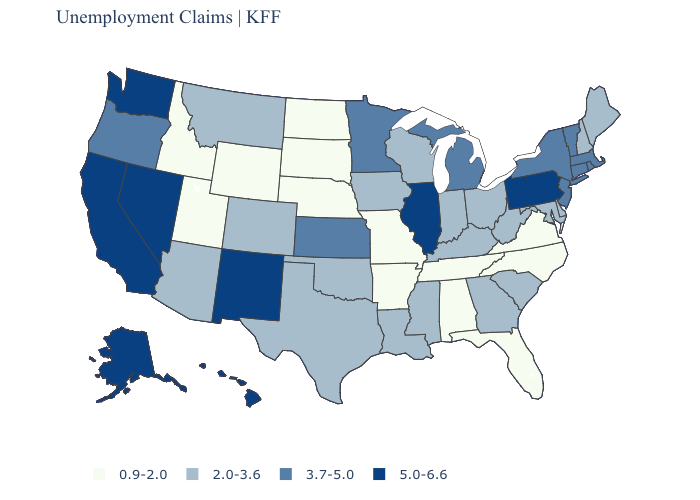Does Vermont have the lowest value in the USA?
Be succinct. No. Does Washington have the highest value in the West?
Answer briefly. Yes. Which states have the lowest value in the Northeast?
Concise answer only. Maine, New Hampshire. What is the highest value in the USA?
Be succinct. 5.0-6.6. Does Minnesota have the lowest value in the USA?
Short answer required. No. Name the states that have a value in the range 5.0-6.6?
Be succinct. Alaska, California, Hawaii, Illinois, Nevada, New Mexico, Pennsylvania, Washington. What is the value of Delaware?
Quick response, please. 2.0-3.6. Among the states that border Montana , which have the highest value?
Quick response, please. Idaho, North Dakota, South Dakota, Wyoming. Among the states that border Pennsylvania , does New York have the lowest value?
Give a very brief answer. No. Name the states that have a value in the range 0.9-2.0?
Be succinct. Alabama, Arkansas, Florida, Idaho, Missouri, Nebraska, North Carolina, North Dakota, South Dakota, Tennessee, Utah, Virginia, Wyoming. Name the states that have a value in the range 3.7-5.0?
Give a very brief answer. Connecticut, Kansas, Massachusetts, Michigan, Minnesota, New Jersey, New York, Oregon, Rhode Island, Vermont. What is the highest value in the USA?
Give a very brief answer. 5.0-6.6. What is the highest value in the MidWest ?
Answer briefly. 5.0-6.6. Is the legend a continuous bar?
Answer briefly. No. What is the lowest value in the West?
Be succinct. 0.9-2.0. 